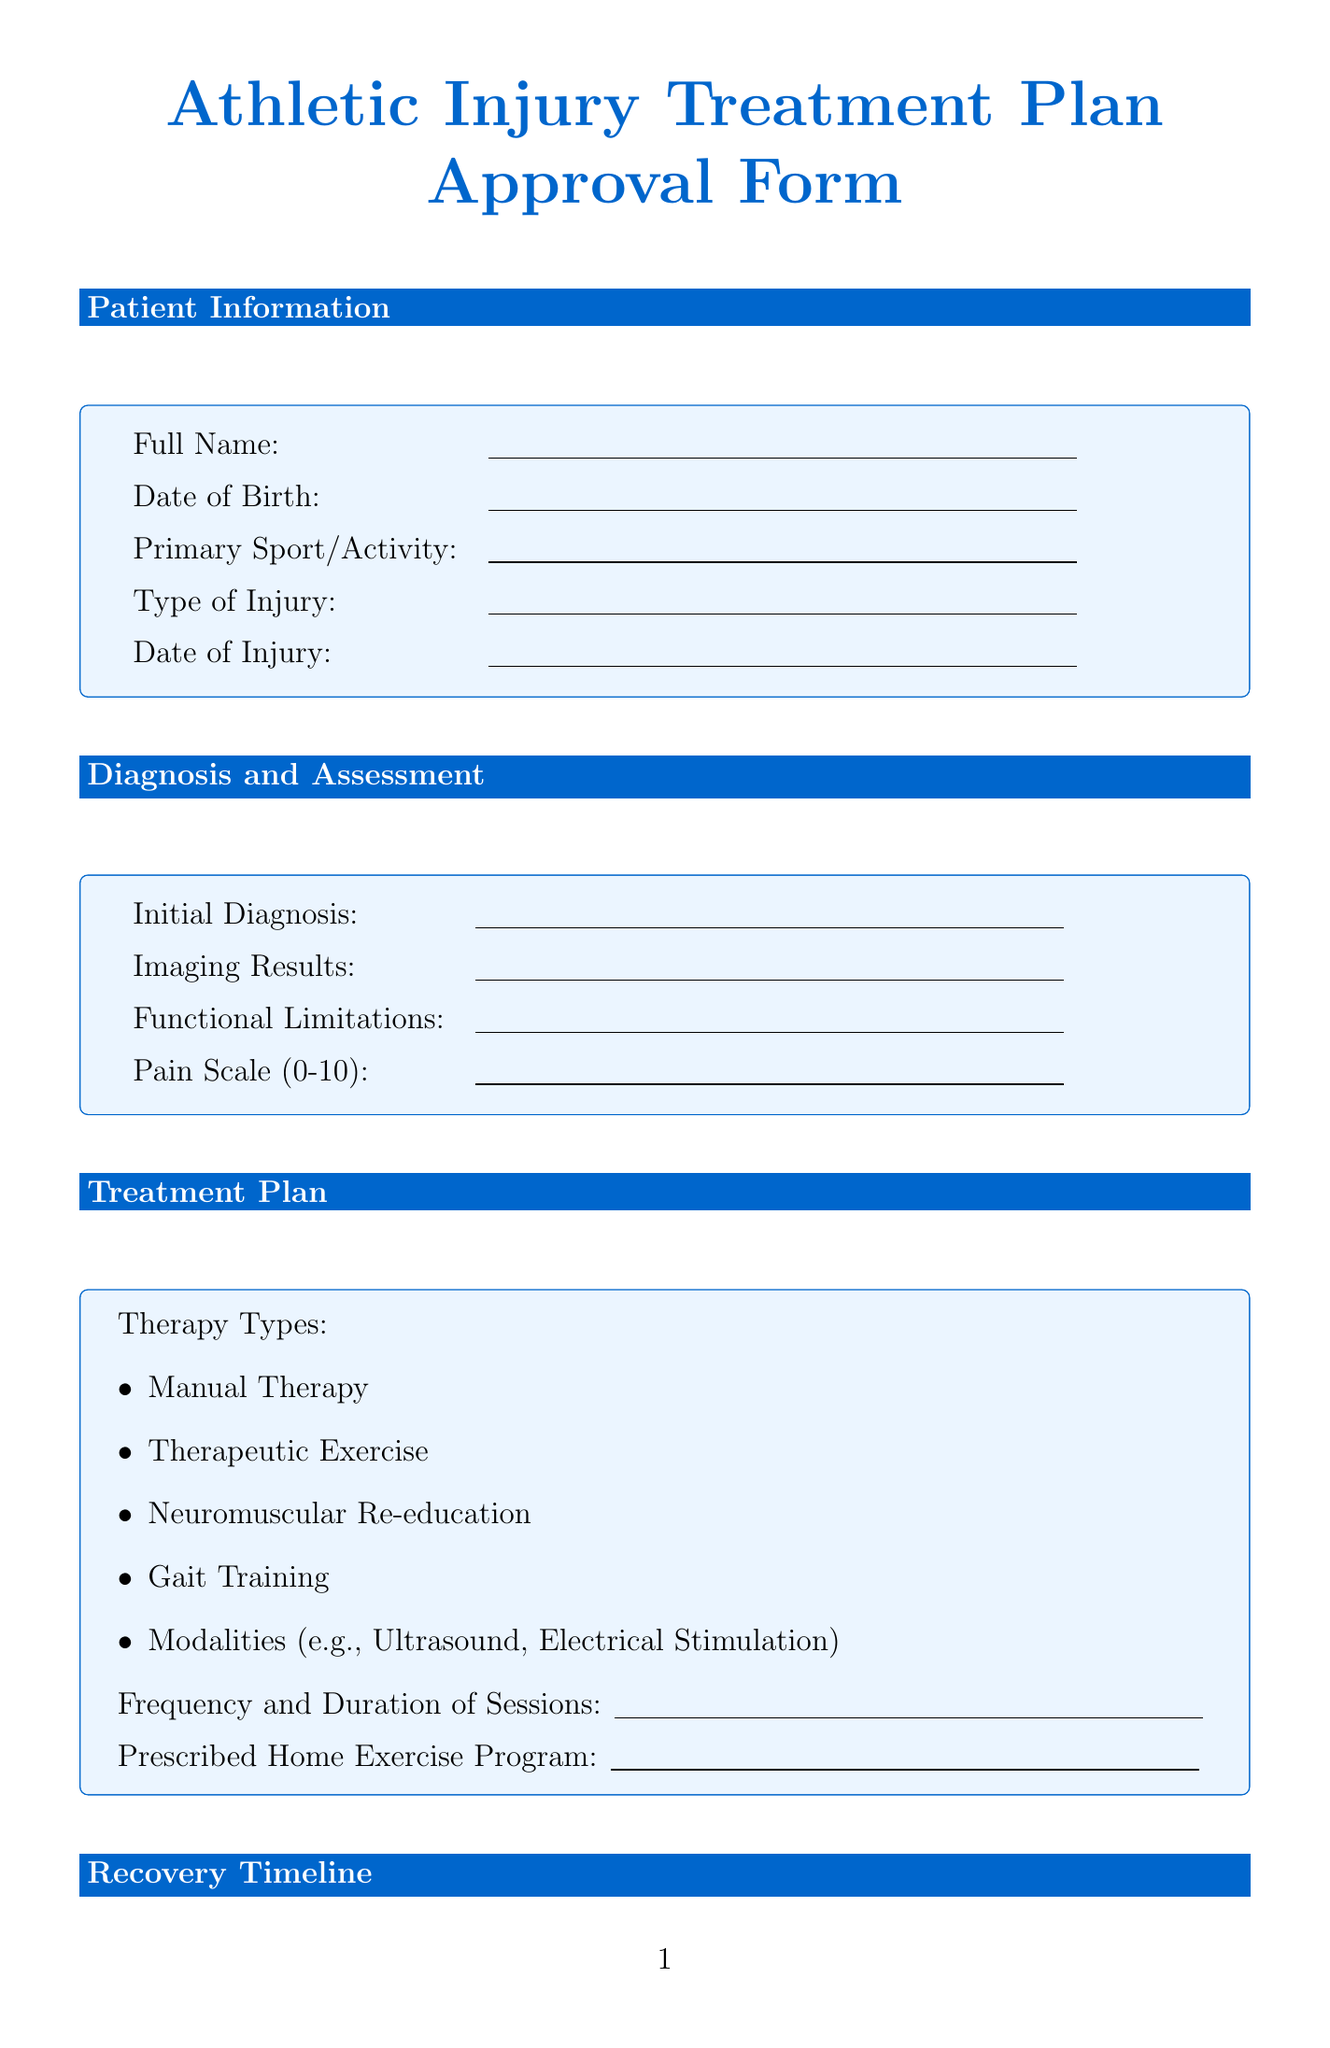What is the patient’s full name? The patient's full name is collected in the document under the patient information section.
Answer: Patient's Full Name What is the initial diagnosis? The initial diagnosis is specified in the diagnosis and assessment section of the document.
Answer: Initial Diagnosis How many authorized sessions are there? The number of authorized sessions is found in the insurance coverage section.
Answer: Number of Authorized Sessions What are the goals of phase 2 recovery? The goals of phase 2 recovery are listed in the recovery timeline section, specifically referring to improvements in the patient's condition.
Answer: Improve range of motion, Increase strength, Begin sport-specific exercises Who needs to sign the approval signatures? The approval signatures section states the individuals who must provide their signatures, which can be found at the end of the document.
Answer: Patient, Referring Physician, Physical Therapist, Insurance Representative 